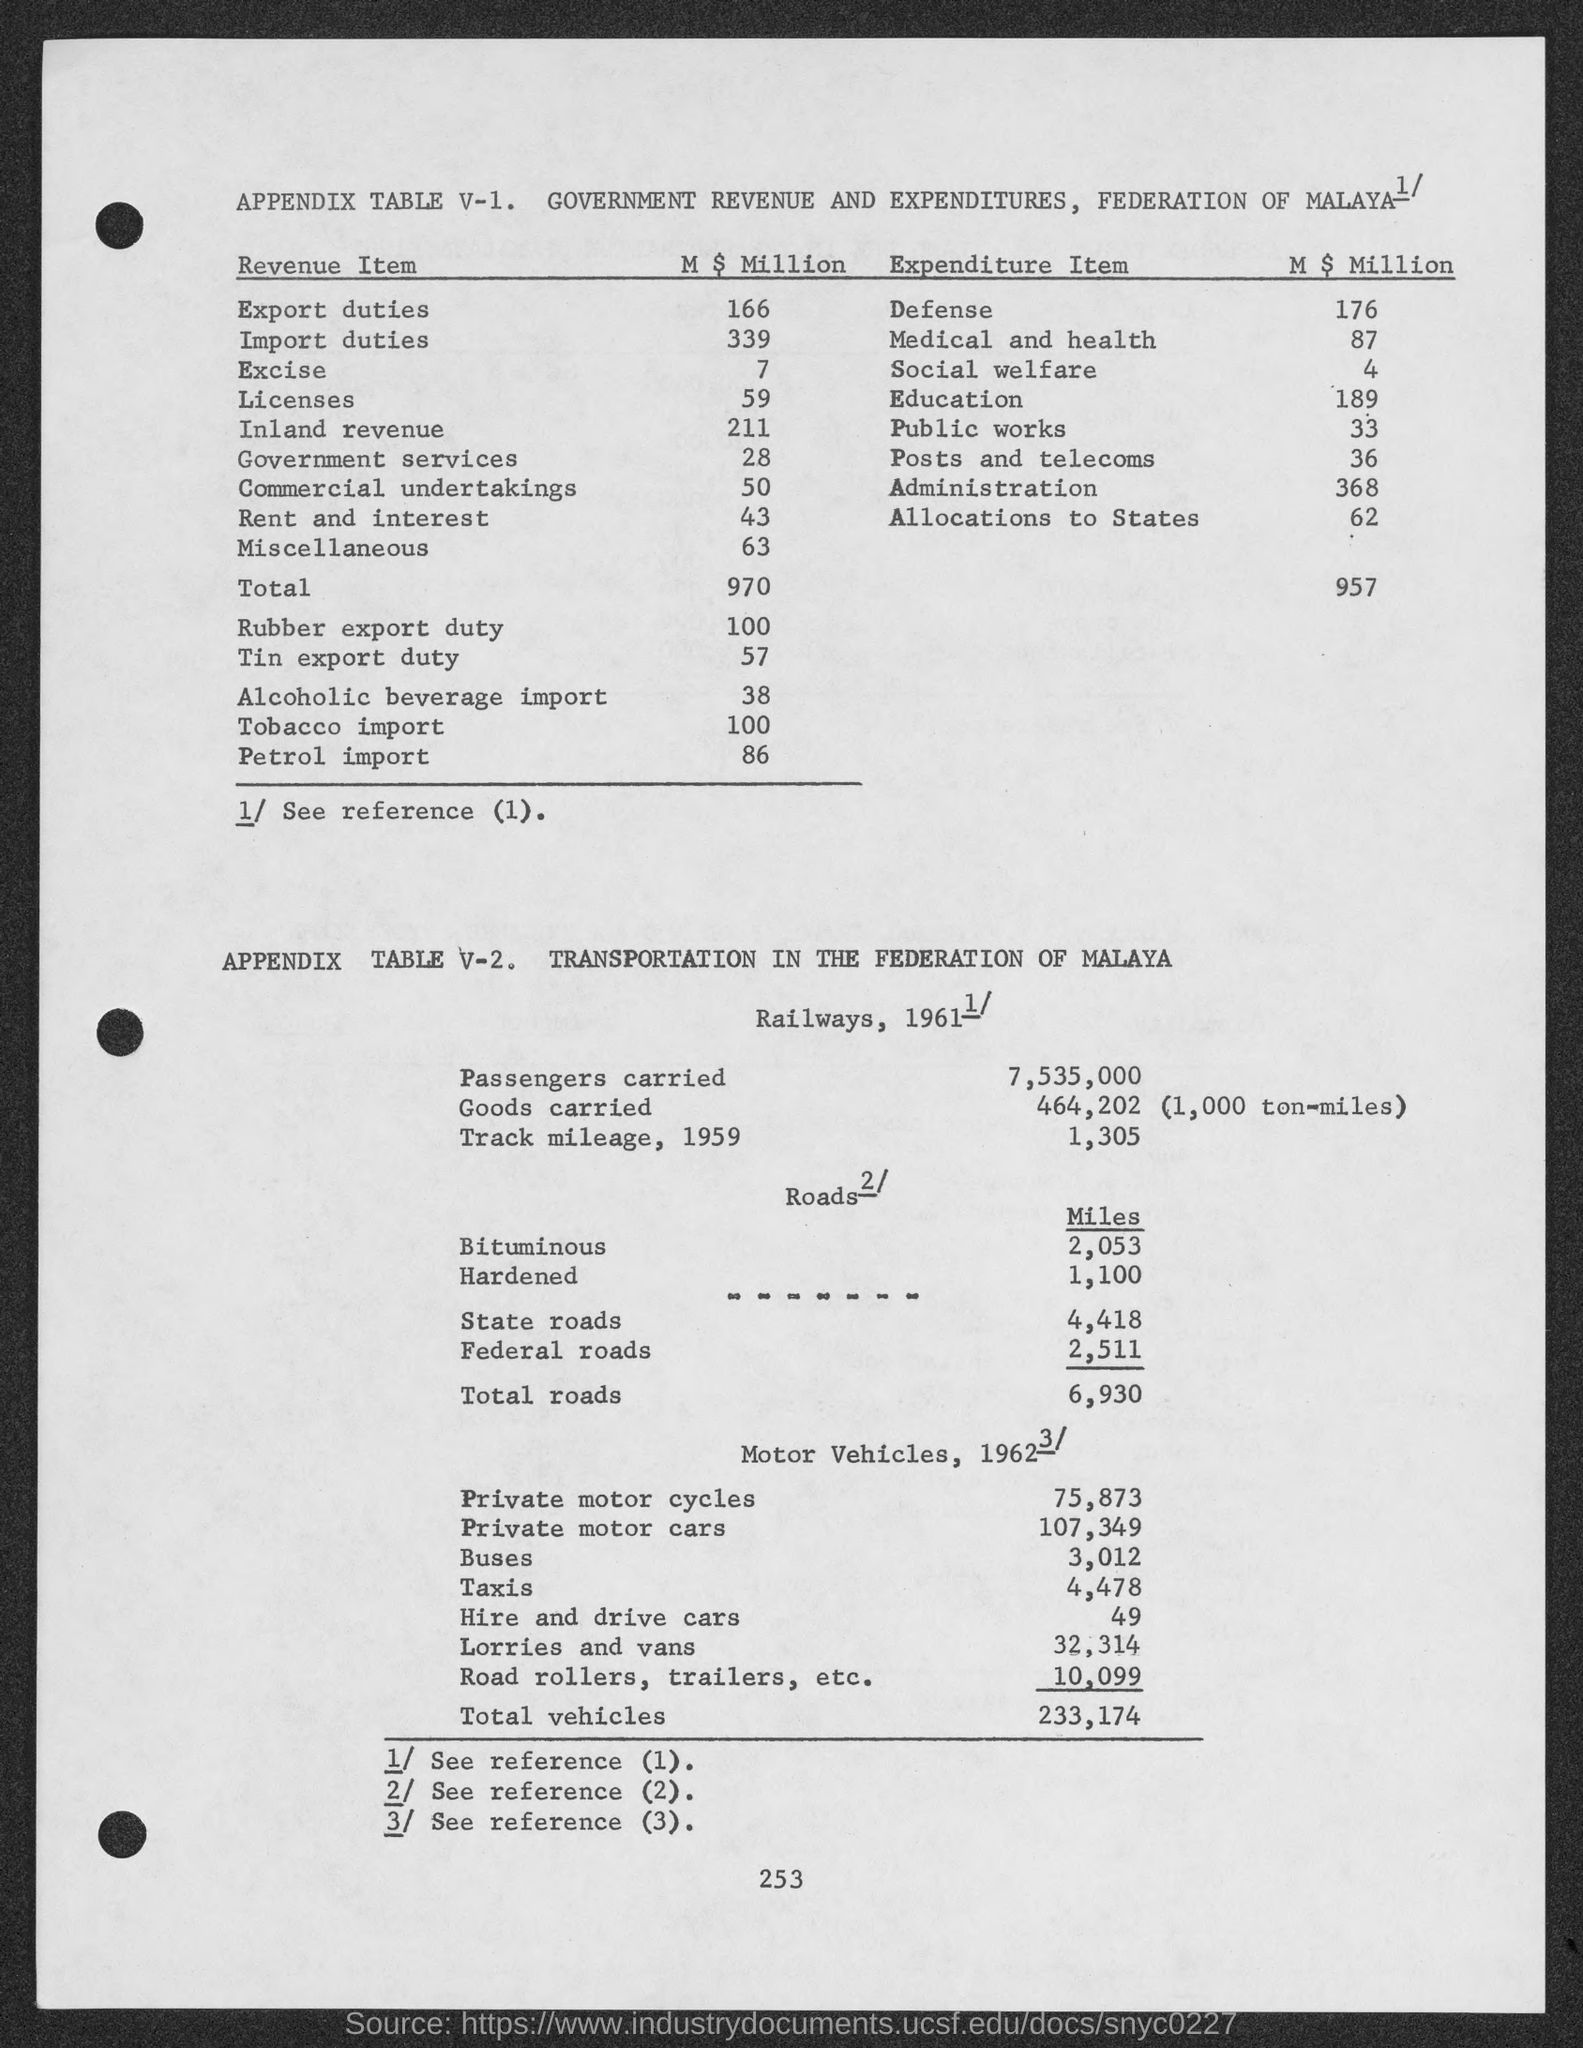Point out several critical features in this image. The total value of export duties in millions of U.S. dollars is 166.. 